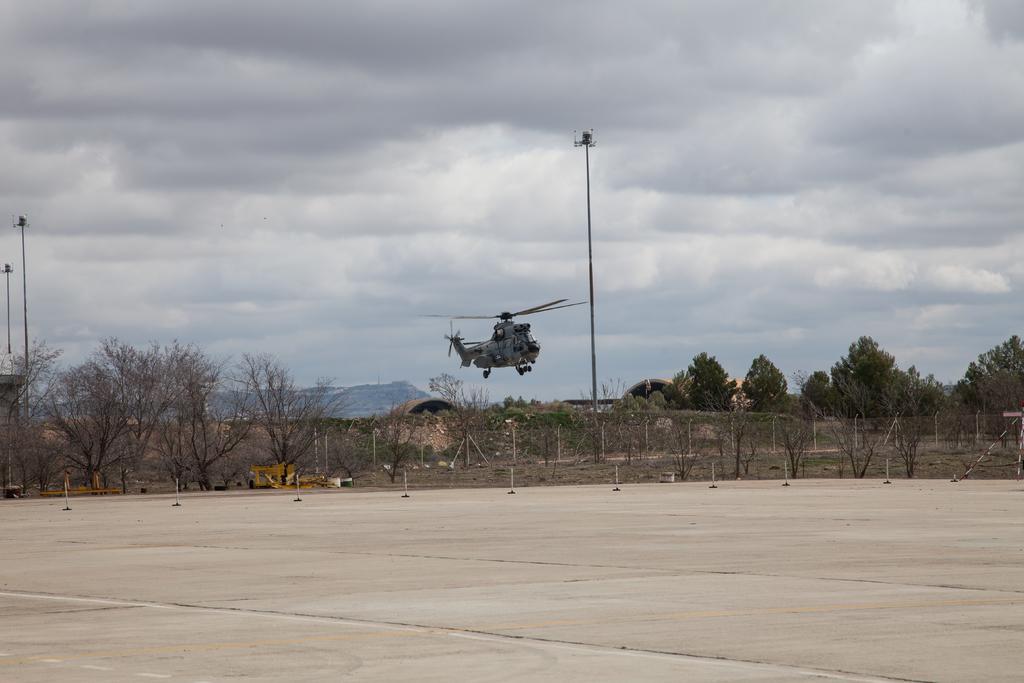Could you give a brief overview of what you see in this image? In this picture we can see the ground, here we can see a helicopter flying and we can see trees, poles and some objects and in the background we can see mountains, sky. 